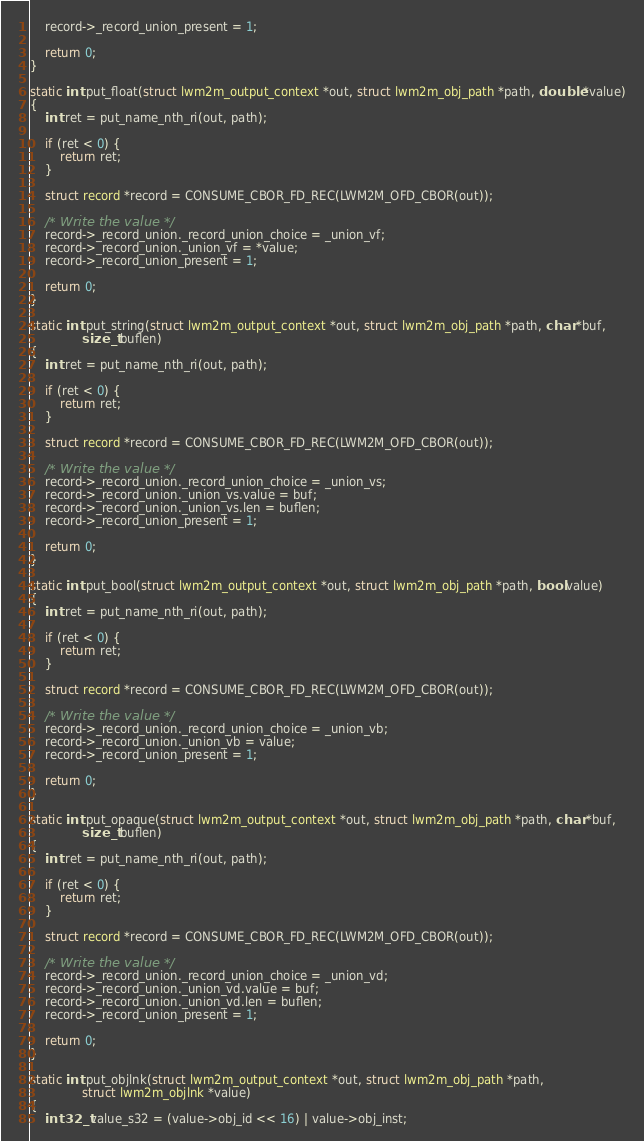Convert code to text. <code><loc_0><loc_0><loc_500><loc_500><_C_>	record->_record_union_present = 1;

	return 0;
}

static int put_float(struct lwm2m_output_context *out, struct lwm2m_obj_path *path, double *value)
{
	int ret = put_name_nth_ri(out, path);

	if (ret < 0) {
		return ret;
	}

	struct record *record = CONSUME_CBOR_FD_REC(LWM2M_OFD_CBOR(out));

	/* Write the value */
	record->_record_union._record_union_choice = _union_vf;
	record->_record_union._union_vf = *value;
	record->_record_union_present = 1;

	return 0;
}

static int put_string(struct lwm2m_output_context *out, struct lwm2m_obj_path *path, char *buf,
		      size_t buflen)
{
	int ret = put_name_nth_ri(out, path);

	if (ret < 0) {
		return ret;
	}

	struct record *record = CONSUME_CBOR_FD_REC(LWM2M_OFD_CBOR(out));

	/* Write the value */
	record->_record_union._record_union_choice = _union_vs;
	record->_record_union._union_vs.value = buf;
	record->_record_union._union_vs.len = buflen;
	record->_record_union_present = 1;

	return 0;
}

static int put_bool(struct lwm2m_output_context *out, struct lwm2m_obj_path *path, bool value)
{
	int ret = put_name_nth_ri(out, path);

	if (ret < 0) {
		return ret;
	}

	struct record *record = CONSUME_CBOR_FD_REC(LWM2M_OFD_CBOR(out));

	/* Write the value */
	record->_record_union._record_union_choice = _union_vb;
	record->_record_union._union_vb = value;
	record->_record_union_present = 1;

	return 0;
}

static int put_opaque(struct lwm2m_output_context *out, struct lwm2m_obj_path *path, char *buf,
		      size_t buflen)
{
	int ret = put_name_nth_ri(out, path);

	if (ret < 0) {
		return ret;
	}

	struct record *record = CONSUME_CBOR_FD_REC(LWM2M_OFD_CBOR(out));

	/* Write the value */
	record->_record_union._record_union_choice = _union_vd;
	record->_record_union._union_vd.value = buf;
	record->_record_union._union_vd.len = buflen;
	record->_record_union_present = 1;

	return 0;
}

static int put_objlnk(struct lwm2m_output_context *out, struct lwm2m_obj_path *path,
		      struct lwm2m_objlnk *value)
{
	int32_t value_s32 = (value->obj_id << 16) | value->obj_inst;
</code> 